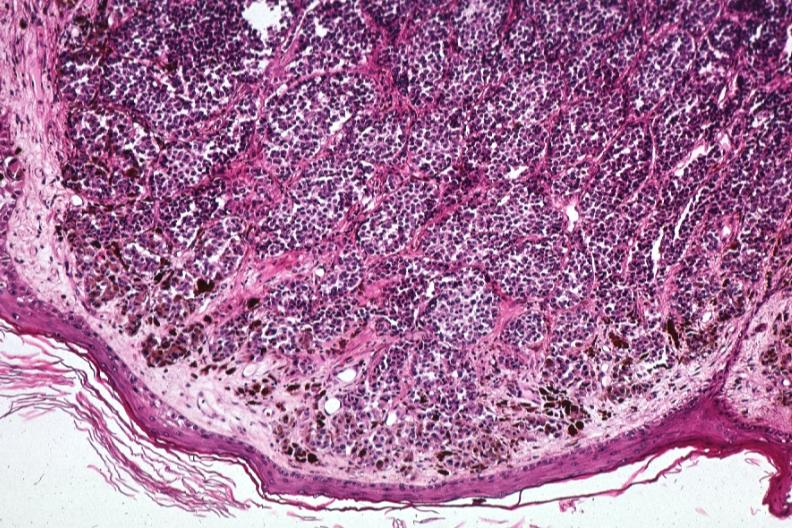where is this?
Answer the question using a single word or phrase. Skin 